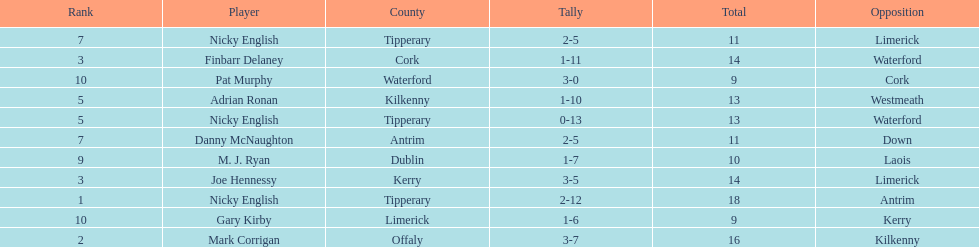What was the mean of the sums of nicky english and mark corrigan? 17. 